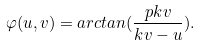<formula> <loc_0><loc_0><loc_500><loc_500>\varphi ( u , v ) = a r c t a n ( \frac { p k v } { k v - u } ) .</formula> 